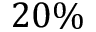Convert formula to latex. <formula><loc_0><loc_0><loc_500><loc_500>2 0 \%</formula> 